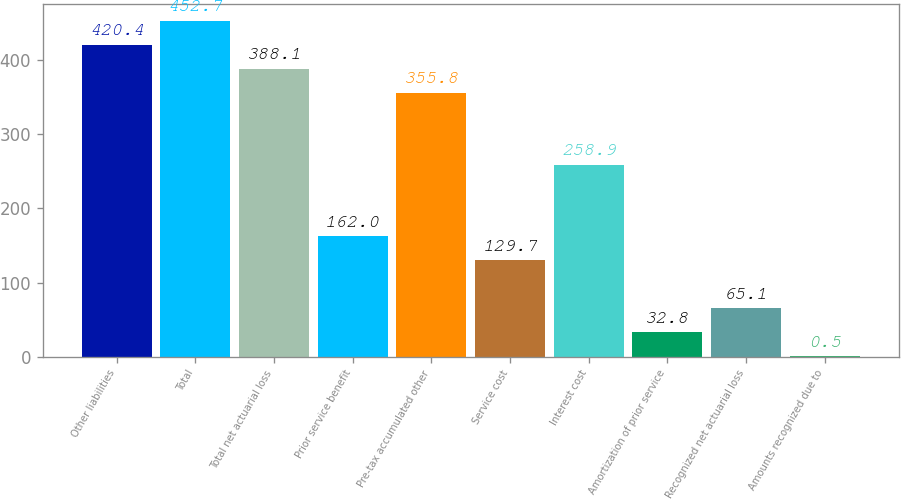Convert chart. <chart><loc_0><loc_0><loc_500><loc_500><bar_chart><fcel>Other liabilities<fcel>Total<fcel>Total net actuarial loss<fcel>Prior service benefit<fcel>Pre-tax accumulated other<fcel>Service cost<fcel>Interest cost<fcel>Amortization of prior service<fcel>Recognized net actuarial loss<fcel>Amounts recognized due to<nl><fcel>420.4<fcel>452.7<fcel>388.1<fcel>162<fcel>355.8<fcel>129.7<fcel>258.9<fcel>32.8<fcel>65.1<fcel>0.5<nl></chart> 